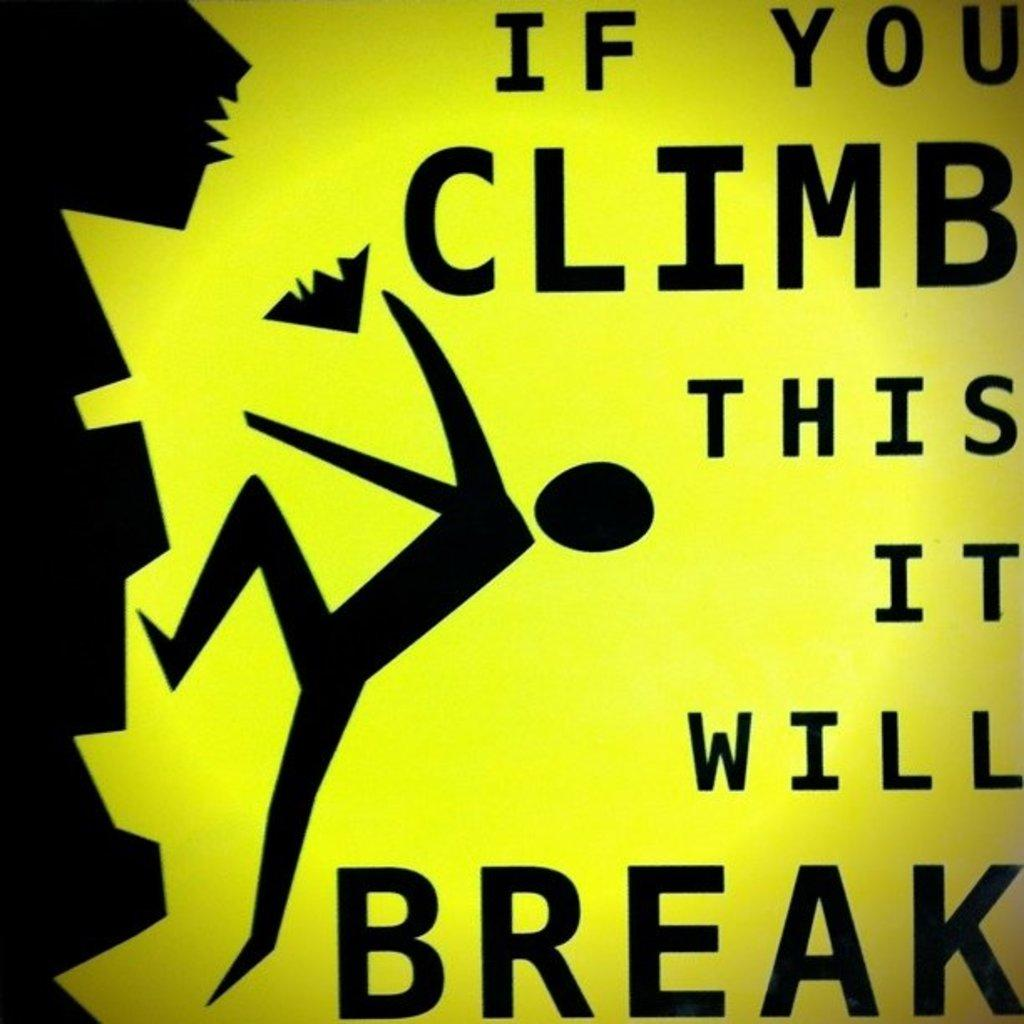<image>
Give a short and clear explanation of the subsequent image. A yellow and black sign that is explaining the dangers of climbing on something. 